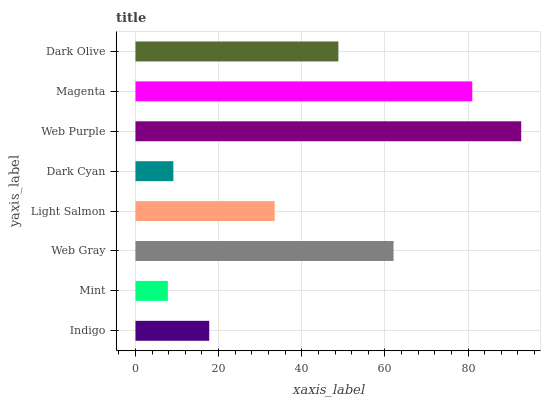Is Mint the minimum?
Answer yes or no. Yes. Is Web Purple the maximum?
Answer yes or no. Yes. Is Web Gray the minimum?
Answer yes or no. No. Is Web Gray the maximum?
Answer yes or no. No. Is Web Gray greater than Mint?
Answer yes or no. Yes. Is Mint less than Web Gray?
Answer yes or no. Yes. Is Mint greater than Web Gray?
Answer yes or no. No. Is Web Gray less than Mint?
Answer yes or no. No. Is Dark Olive the high median?
Answer yes or no. Yes. Is Light Salmon the low median?
Answer yes or no. Yes. Is Light Salmon the high median?
Answer yes or no. No. Is Web Purple the low median?
Answer yes or no. No. 